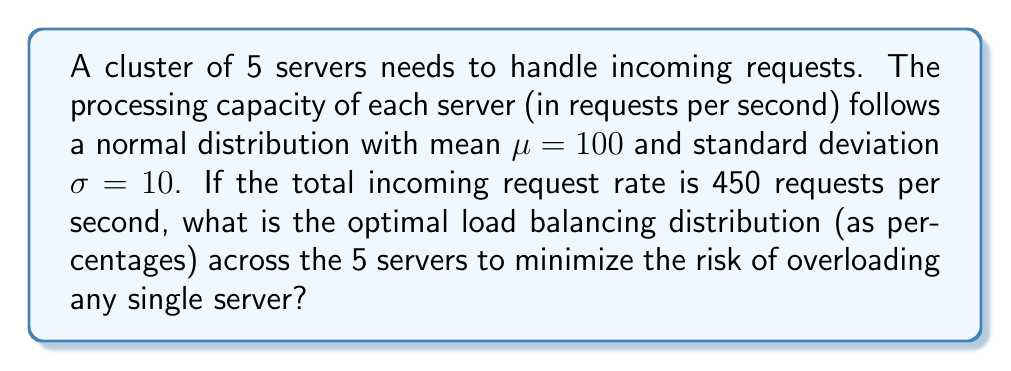Provide a solution to this math problem. To solve this problem, we'll follow these steps:

1) First, we need to understand that the optimal distribution should be proportional to each server's capacity. Since all servers follow the same normal distribution, their expected capacities are equal.

2) The total expected capacity of the cluster is:
   $$5 \times 100 = 500$$ requests per second

3) The incoming request rate (450 r/s) is 90% of the total expected capacity:
   $$\frac{450}{500} = 0.9 = 90\%$$

4) To minimize the risk of overloading, we should distribute the load equally among all servers, as they have the same capacity distribution.

5) The optimal distribution for each server is:
   $$\frac{1}{5} = 0.2 = 20\%$$ of the total incoming requests

6) To verify, 20% of 450 r/s is 90 r/s for each server, which is below the mean capacity (100 r/s) and reduces the risk of overload.

7) Converting to percentages:
   $$20\% \text{ for each of the 5 servers}$$

This distribution ensures that each server operates at 90% of its expected capacity, providing a buffer for capacity fluctuations and minimizing overload risk.
Answer: 20%, 20%, 20%, 20%, 20% 